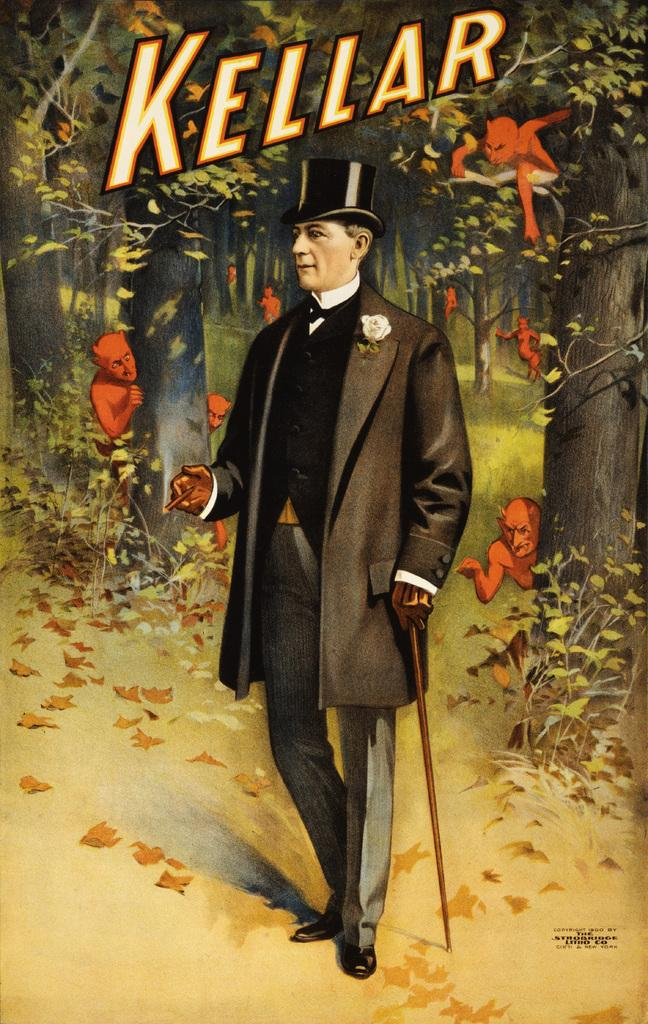What type of artwork is depicted in the image? The image is a painting. Can you describe the main subject of the painting? There is a man standing in the middle of the painting. What is the man wearing in the painting? The man is wearing a coat, trouser, and hat. What can be seen in the background of the painting? There are ghosts on the trees in the background of the painting. Is there any text present in the painting? Yes, there is a name at the top of the painting. What type of marble is used for the floor in the painting? There is no mention of a floor or marble in the painting; it primarily features a man, his attire, and ghosts on trees. 